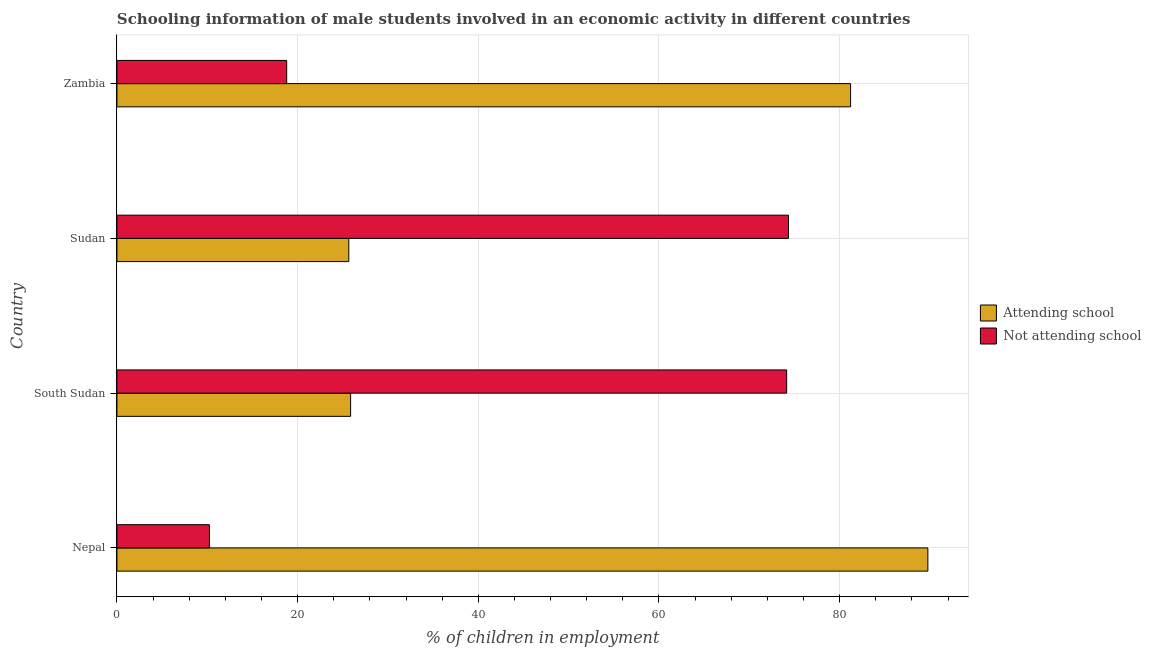How many groups of bars are there?
Your response must be concise. 4. Are the number of bars on each tick of the Y-axis equal?
Offer a terse response. Yes. How many bars are there on the 2nd tick from the top?
Ensure brevity in your answer.  2. How many bars are there on the 2nd tick from the bottom?
Your answer should be very brief. 2. What is the label of the 1st group of bars from the top?
Provide a succinct answer. Zambia. What is the percentage of employed males who are attending school in Nepal?
Ensure brevity in your answer.  89.76. Across all countries, what is the maximum percentage of employed males who are not attending school?
Give a very brief answer. 74.33. Across all countries, what is the minimum percentage of employed males who are attending school?
Your answer should be very brief. 25.67. In which country was the percentage of employed males who are not attending school maximum?
Your answer should be very brief. Sudan. In which country was the percentage of employed males who are attending school minimum?
Ensure brevity in your answer.  Sudan. What is the total percentage of employed males who are attending school in the graph?
Give a very brief answer. 222.51. What is the difference between the percentage of employed males who are not attending school in Nepal and that in South Sudan?
Offer a very short reply. -63.9. What is the difference between the percentage of employed males who are not attending school in Zambia and the percentage of employed males who are attending school in South Sudan?
Provide a short and direct response. -7.08. What is the average percentage of employed males who are attending school per country?
Give a very brief answer. 55.63. What is the difference between the percentage of employed males who are attending school and percentage of employed males who are not attending school in Zambia?
Your response must be concise. 62.42. What is the ratio of the percentage of employed males who are not attending school in Nepal to that in South Sudan?
Offer a very short reply. 0.14. Is the difference between the percentage of employed males who are attending school in Nepal and Zambia greater than the difference between the percentage of employed males who are not attending school in Nepal and Zambia?
Offer a terse response. Yes. What is the difference between the highest and the second highest percentage of employed males who are attending school?
Your response must be concise. 8.55. What is the difference between the highest and the lowest percentage of employed males who are attending school?
Ensure brevity in your answer.  64.1. What does the 1st bar from the top in Sudan represents?
Your answer should be compact. Not attending school. What does the 2nd bar from the bottom in Sudan represents?
Your answer should be very brief. Not attending school. How many bars are there?
Give a very brief answer. 8. Are all the bars in the graph horizontal?
Give a very brief answer. Yes. Are the values on the major ticks of X-axis written in scientific E-notation?
Provide a short and direct response. No. Does the graph contain any zero values?
Provide a succinct answer. No. Where does the legend appear in the graph?
Provide a short and direct response. Center right. How many legend labels are there?
Your answer should be very brief. 2. What is the title of the graph?
Offer a terse response. Schooling information of male students involved in an economic activity in different countries. Does "Foreign liabilities" appear as one of the legend labels in the graph?
Make the answer very short. No. What is the label or title of the X-axis?
Your answer should be compact. % of children in employment. What is the label or title of the Y-axis?
Make the answer very short. Country. What is the % of children in employment of Attending school in Nepal?
Offer a very short reply. 89.76. What is the % of children in employment of Not attending school in Nepal?
Keep it short and to the point. 10.24. What is the % of children in employment of Attending school in South Sudan?
Provide a succinct answer. 25.87. What is the % of children in employment of Not attending school in South Sudan?
Give a very brief answer. 74.13. What is the % of children in employment of Attending school in Sudan?
Keep it short and to the point. 25.67. What is the % of children in employment of Not attending school in Sudan?
Give a very brief answer. 74.33. What is the % of children in employment of Attending school in Zambia?
Offer a very short reply. 81.21. What is the % of children in employment in Not attending school in Zambia?
Keep it short and to the point. 18.79. Across all countries, what is the maximum % of children in employment of Attending school?
Provide a succinct answer. 89.76. Across all countries, what is the maximum % of children in employment of Not attending school?
Provide a succinct answer. 74.33. Across all countries, what is the minimum % of children in employment in Attending school?
Your answer should be compact. 25.67. Across all countries, what is the minimum % of children in employment in Not attending school?
Your answer should be compact. 10.24. What is the total % of children in employment of Attending school in the graph?
Your answer should be compact. 222.5. What is the total % of children in employment of Not attending school in the graph?
Give a very brief answer. 177.5. What is the difference between the % of children in employment in Attending school in Nepal and that in South Sudan?
Offer a very short reply. 63.9. What is the difference between the % of children in employment of Not attending school in Nepal and that in South Sudan?
Your response must be concise. -63.9. What is the difference between the % of children in employment in Attending school in Nepal and that in Sudan?
Your response must be concise. 64.1. What is the difference between the % of children in employment in Not attending school in Nepal and that in Sudan?
Ensure brevity in your answer.  -64.1. What is the difference between the % of children in employment of Attending school in Nepal and that in Zambia?
Ensure brevity in your answer.  8.55. What is the difference between the % of children in employment of Not attending school in Nepal and that in Zambia?
Your answer should be very brief. -8.55. What is the difference between the % of children in employment of Attending school in South Sudan and that in Sudan?
Make the answer very short. 0.2. What is the difference between the % of children in employment of Not attending school in South Sudan and that in Sudan?
Keep it short and to the point. -0.2. What is the difference between the % of children in employment of Attending school in South Sudan and that in Zambia?
Make the answer very short. -55.34. What is the difference between the % of children in employment of Not attending school in South Sudan and that in Zambia?
Keep it short and to the point. 55.34. What is the difference between the % of children in employment in Attending school in Sudan and that in Zambia?
Provide a short and direct response. -55.55. What is the difference between the % of children in employment in Not attending school in Sudan and that in Zambia?
Make the answer very short. 55.55. What is the difference between the % of children in employment in Attending school in Nepal and the % of children in employment in Not attending school in South Sudan?
Keep it short and to the point. 15.63. What is the difference between the % of children in employment in Attending school in Nepal and the % of children in employment in Not attending school in Sudan?
Make the answer very short. 15.43. What is the difference between the % of children in employment in Attending school in Nepal and the % of children in employment in Not attending school in Zambia?
Offer a very short reply. 70.97. What is the difference between the % of children in employment of Attending school in South Sudan and the % of children in employment of Not attending school in Sudan?
Your answer should be compact. -48.47. What is the difference between the % of children in employment of Attending school in South Sudan and the % of children in employment of Not attending school in Zambia?
Offer a very short reply. 7.08. What is the difference between the % of children in employment in Attending school in Sudan and the % of children in employment in Not attending school in Zambia?
Provide a short and direct response. 6.88. What is the average % of children in employment in Attending school per country?
Make the answer very short. 55.63. What is the average % of children in employment in Not attending school per country?
Provide a succinct answer. 44.37. What is the difference between the % of children in employment of Attending school and % of children in employment of Not attending school in Nepal?
Ensure brevity in your answer.  79.53. What is the difference between the % of children in employment in Attending school and % of children in employment in Not attending school in South Sudan?
Your answer should be compact. -48.27. What is the difference between the % of children in employment of Attending school and % of children in employment of Not attending school in Sudan?
Give a very brief answer. -48.67. What is the difference between the % of children in employment in Attending school and % of children in employment in Not attending school in Zambia?
Give a very brief answer. 62.42. What is the ratio of the % of children in employment in Attending school in Nepal to that in South Sudan?
Give a very brief answer. 3.47. What is the ratio of the % of children in employment in Not attending school in Nepal to that in South Sudan?
Ensure brevity in your answer.  0.14. What is the ratio of the % of children in employment in Attending school in Nepal to that in Sudan?
Keep it short and to the point. 3.5. What is the ratio of the % of children in employment in Not attending school in Nepal to that in Sudan?
Your answer should be very brief. 0.14. What is the ratio of the % of children in employment in Attending school in Nepal to that in Zambia?
Ensure brevity in your answer.  1.11. What is the ratio of the % of children in employment in Not attending school in Nepal to that in Zambia?
Provide a short and direct response. 0.54. What is the ratio of the % of children in employment of Not attending school in South Sudan to that in Sudan?
Your answer should be compact. 1. What is the ratio of the % of children in employment of Attending school in South Sudan to that in Zambia?
Your answer should be compact. 0.32. What is the ratio of the % of children in employment of Not attending school in South Sudan to that in Zambia?
Provide a succinct answer. 3.95. What is the ratio of the % of children in employment of Attending school in Sudan to that in Zambia?
Keep it short and to the point. 0.32. What is the ratio of the % of children in employment in Not attending school in Sudan to that in Zambia?
Ensure brevity in your answer.  3.96. What is the difference between the highest and the second highest % of children in employment of Attending school?
Keep it short and to the point. 8.55. What is the difference between the highest and the second highest % of children in employment of Not attending school?
Offer a very short reply. 0.2. What is the difference between the highest and the lowest % of children in employment of Attending school?
Provide a succinct answer. 64.1. What is the difference between the highest and the lowest % of children in employment of Not attending school?
Provide a short and direct response. 64.1. 